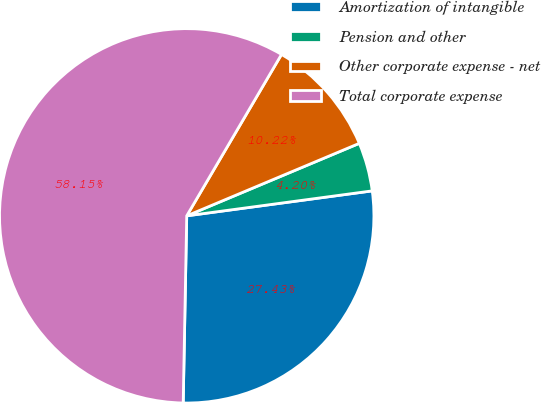Convert chart to OTSL. <chart><loc_0><loc_0><loc_500><loc_500><pie_chart><fcel>Amortization of intangible<fcel>Pension and other<fcel>Other corporate expense - net<fcel>Total corporate expense<nl><fcel>27.43%<fcel>4.2%<fcel>10.22%<fcel>58.15%<nl></chart> 